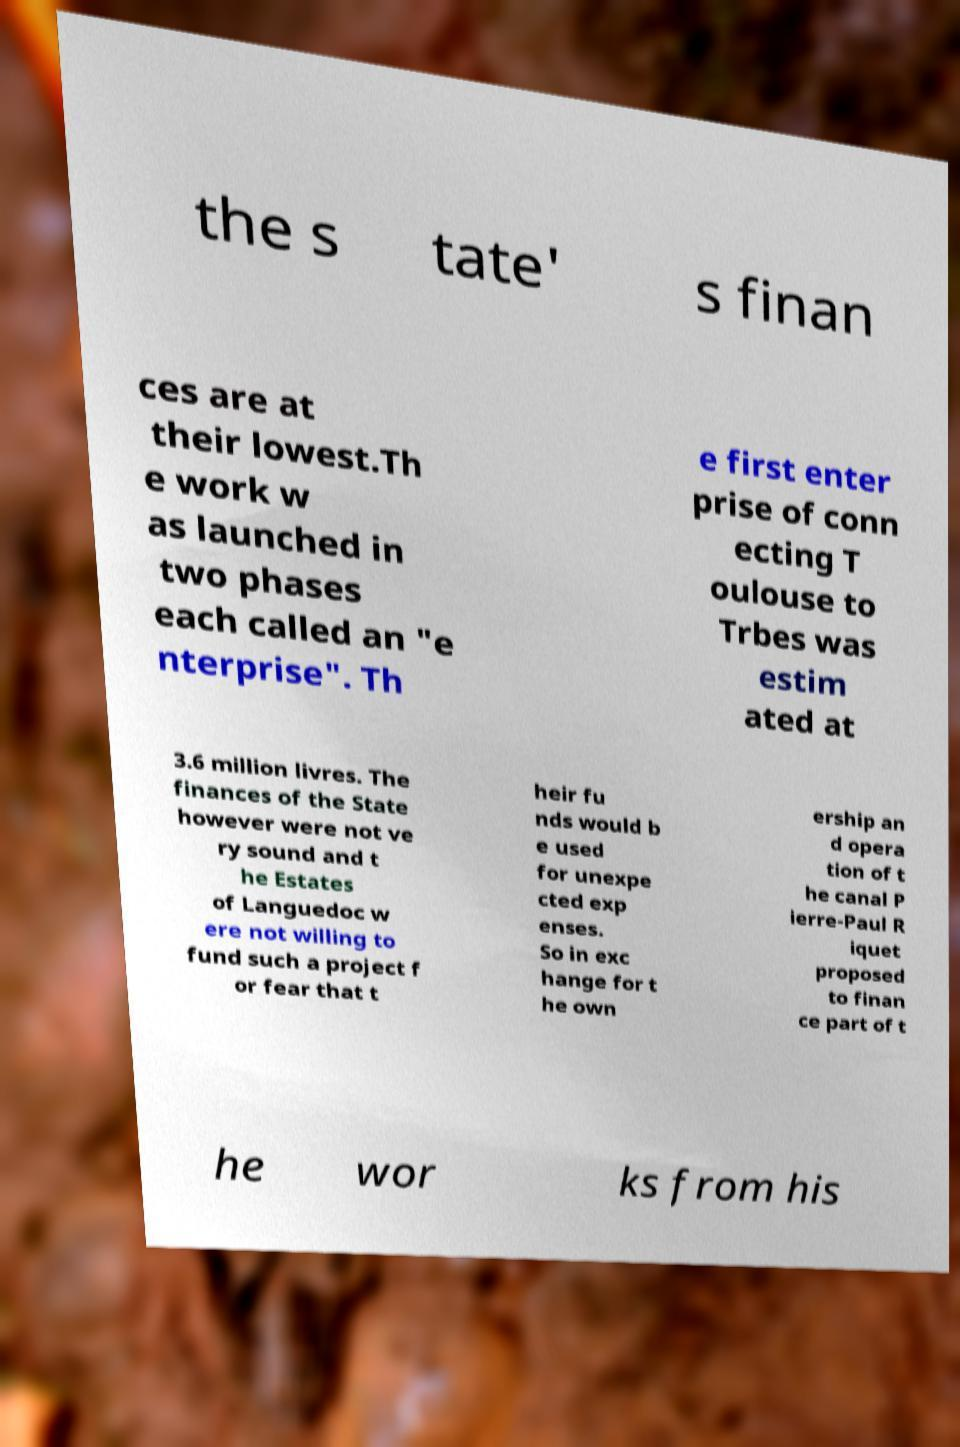Could you assist in decoding the text presented in this image and type it out clearly? the s tate' s finan ces are at their lowest.Th e work w as launched in two phases each called an "e nterprise". Th e first enter prise of conn ecting T oulouse to Trbes was estim ated at 3.6 million livres. The finances of the State however were not ve ry sound and t he Estates of Languedoc w ere not willing to fund such a project f or fear that t heir fu nds would b e used for unexpe cted exp enses. So in exc hange for t he own ership an d opera tion of t he canal P ierre-Paul R iquet proposed to finan ce part of t he wor ks from his 